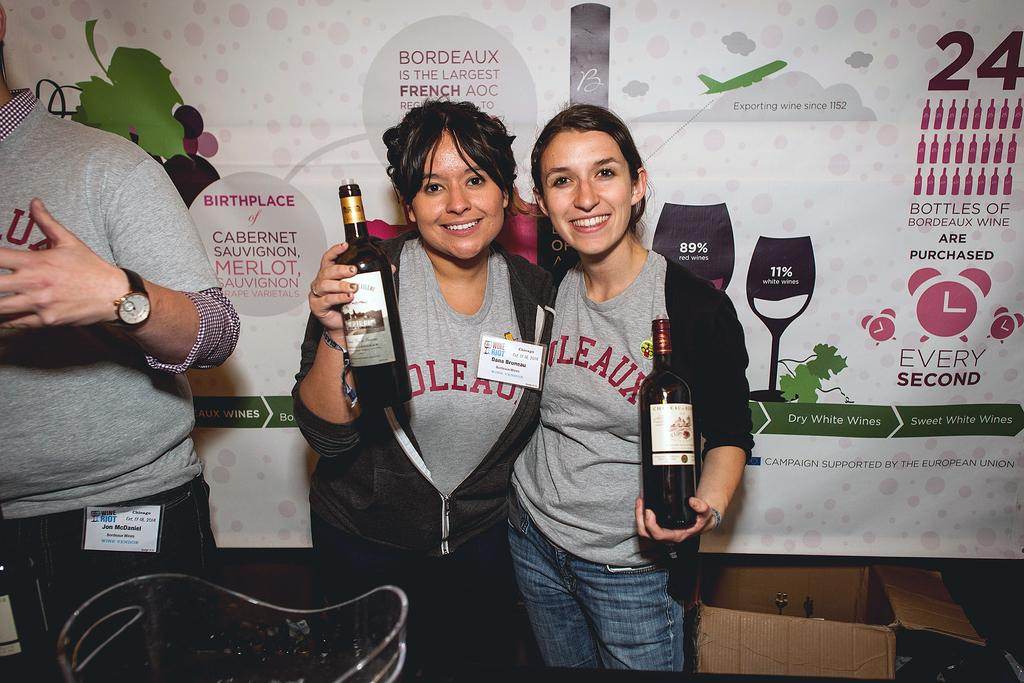How many people are in the image? There are 2 people standing in the image. What are the people holding in their hands? The people are holding glass bottles. Which side of the image does the person on the left stand? There is a person on the left side of the image. What else can be seen in the image besides the people? There is a carton and a banner in the image. How much sugar is in the flame in the image? There is no sugar or flame present in the image. What type of visitor can be seen interacting with the people in the image? There is no visitor present in the image; only the two people and the objects mentioned in the facts are visible. 